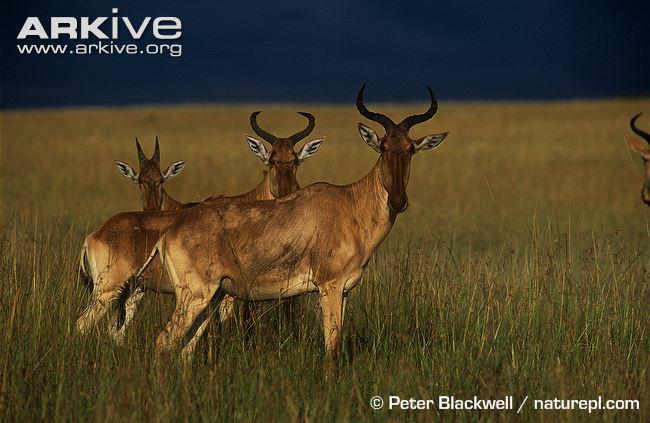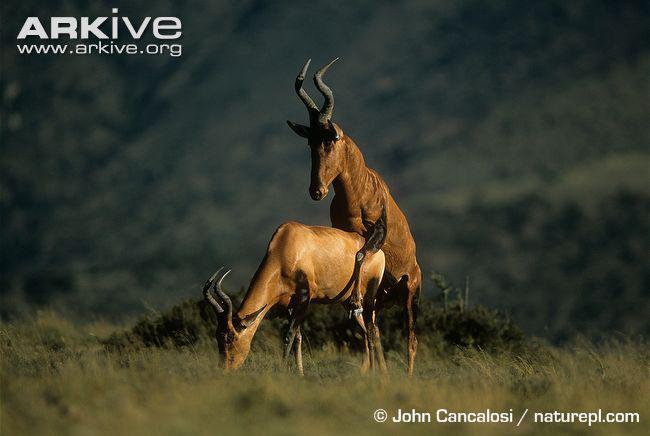The first image is the image on the left, the second image is the image on the right. Given the left and right images, does the statement "Each image contains a single horned animal, which is standing on all four legs with its body in profile." hold true? Answer yes or no. No. The first image is the image on the left, the second image is the image on the right. Examine the images to the left and right. Is the description "There are exactly two goats." accurate? Answer yes or no. No. 